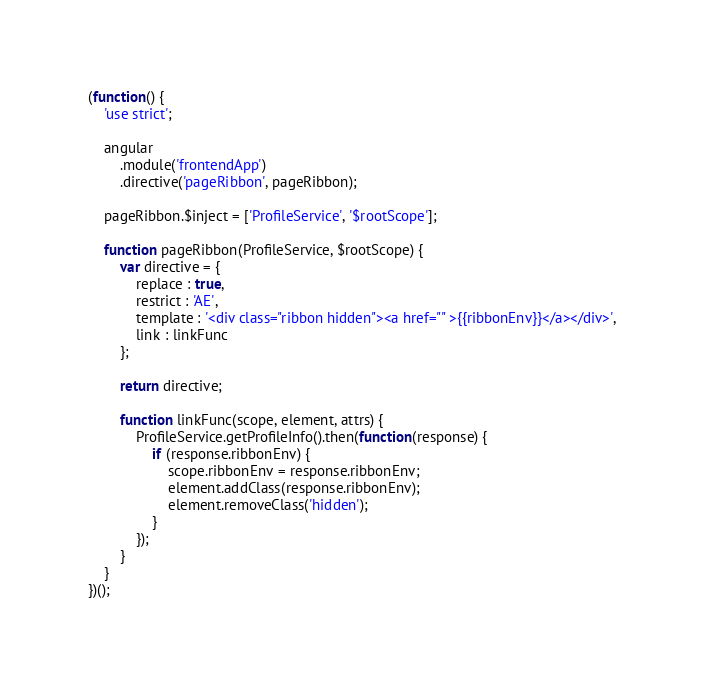<code> <loc_0><loc_0><loc_500><loc_500><_JavaScript_>(function() {
    'use strict';

    angular
        .module('frontendApp')
        .directive('pageRibbon', pageRibbon);

    pageRibbon.$inject = ['ProfileService', '$rootScope'];

    function pageRibbon(ProfileService, $rootScope) {
        var directive = {
            replace : true,
            restrict : 'AE',
            template : '<div class="ribbon hidden"><a href="" >{{ribbonEnv}}</a></div>',
            link : linkFunc
        };

        return directive;

        function linkFunc(scope, element, attrs) {
            ProfileService.getProfileInfo().then(function(response) {
                if (response.ribbonEnv) {
                    scope.ribbonEnv = response.ribbonEnv;
                    element.addClass(response.ribbonEnv);
                    element.removeClass('hidden');
                }
            });
        }
    }
})();
</code> 